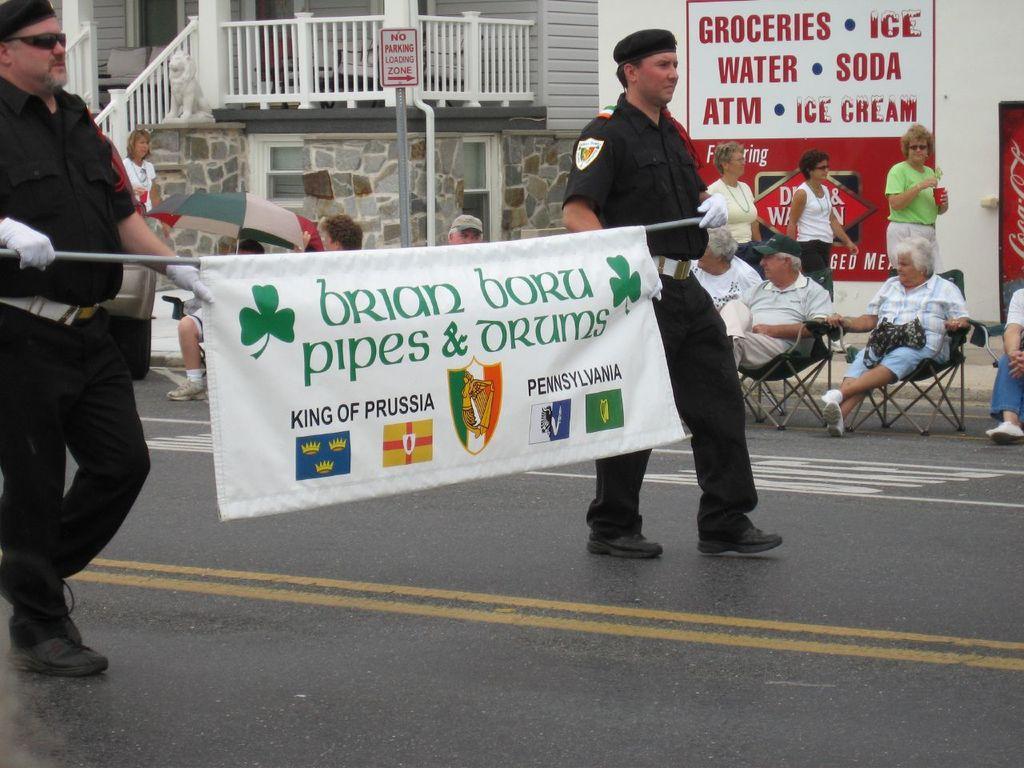How would you summarize this image in a sentence or two? On the left side, there is a person in black color dress, holding banner with one hand, holding stick of this banner with other hand and walking on the road. On the right side, there is another person in black color dress, holding this banner with one hand, holding stick of this banner with other hand and walking on the road. In the background, there are persons sitting on chairs, walking on the road, there are persons on the footpath, painting on the wall of the building, there is a signboard and there is fencing. 